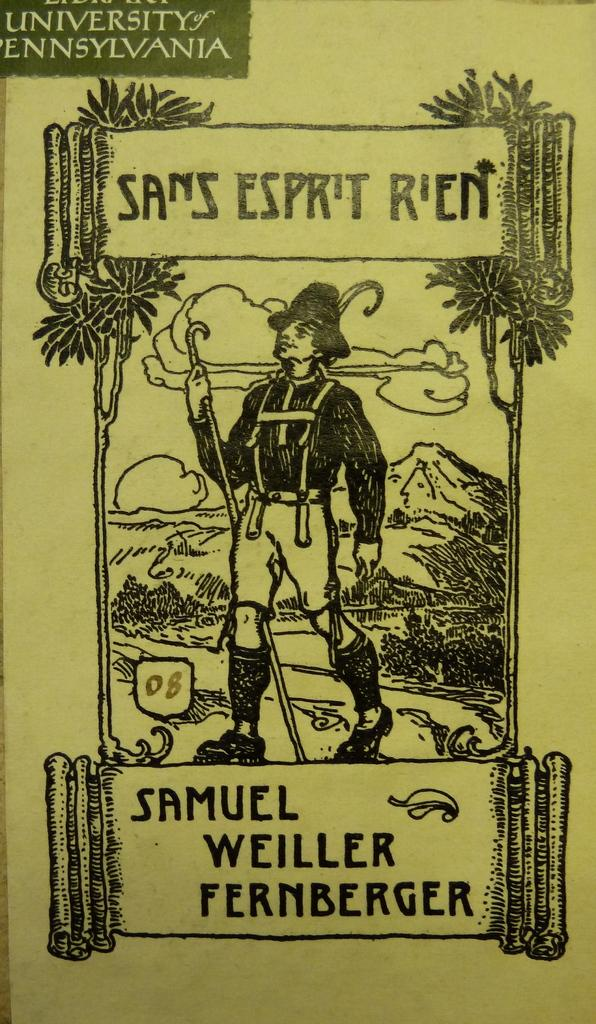<image>
Describe the image concisely. A University of Pennsylvania Samuel Weiller Fernberger advertisement. 